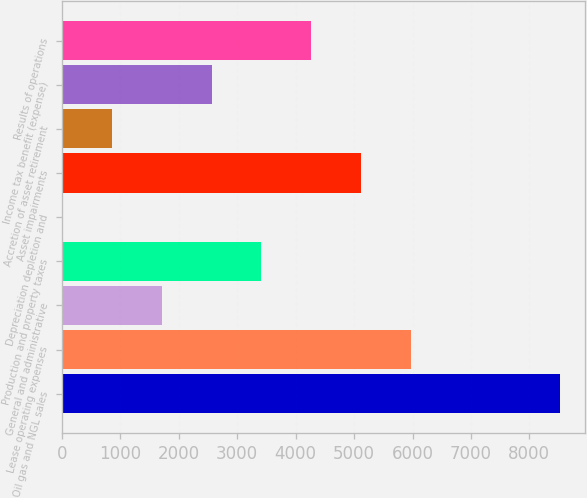Convert chart to OTSL. <chart><loc_0><loc_0><loc_500><loc_500><bar_chart><fcel>Oil gas and NGL sales<fcel>Lease operating expenses<fcel>General and administrative<fcel>Production and property taxes<fcel>Depreciation depletion and<fcel>Asset impairments<fcel>Accretion of asset retirement<fcel>Income tax benefit (expense)<fcel>Results of operations<nl><fcel>8522<fcel>5968.34<fcel>1712.2<fcel>3414.65<fcel>9.75<fcel>5117.11<fcel>860.98<fcel>2563.43<fcel>4265.88<nl></chart> 